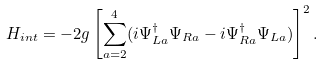Convert formula to latex. <formula><loc_0><loc_0><loc_500><loc_500>H _ { i n t } = - 2 g \left [ \sum ^ { 4 } _ { a = 2 } ( i \Psi ^ { \dagger } _ { L a } \Psi _ { R a } - i \Psi ^ { \dagger } _ { R a } \Psi _ { L a } ) \right ] ^ { 2 } .</formula> 